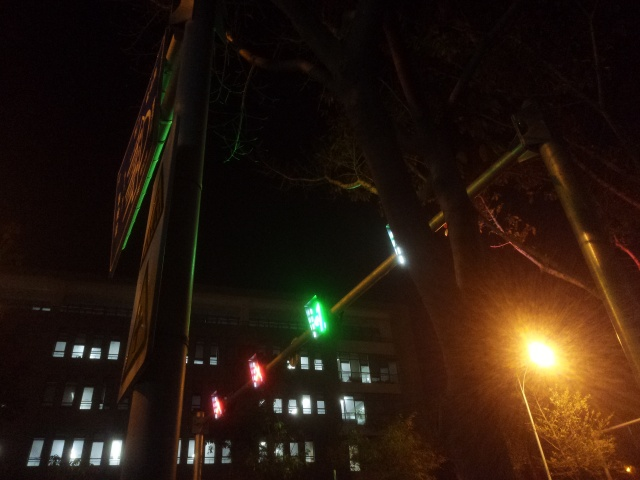Are there any unique features or points of interest in this image? One unique aspect is the traffic signal showing green in multiple directions, which is unusual and could be confusing to drivers. This might be due to a reflection or a glitch in the traffic light. Additionally, the array of lights against the darkness creates a juxtaposition that draws the viewer's attention. 